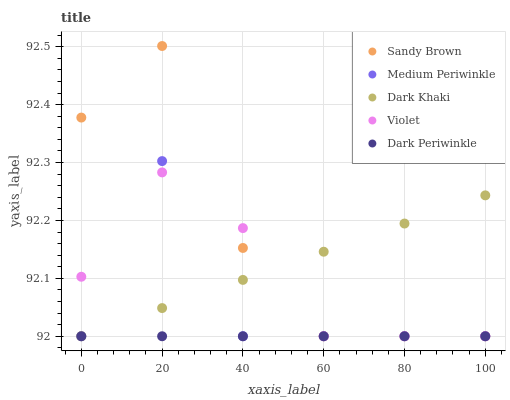Does Dark Periwinkle have the minimum area under the curve?
Answer yes or no. Yes. Does Sandy Brown have the maximum area under the curve?
Answer yes or no. Yes. Does Medium Periwinkle have the minimum area under the curve?
Answer yes or no. No. Does Medium Periwinkle have the maximum area under the curve?
Answer yes or no. No. Is Dark Periwinkle the smoothest?
Answer yes or no. Yes. Is Medium Periwinkle the roughest?
Answer yes or no. Yes. Is Sandy Brown the smoothest?
Answer yes or no. No. Is Sandy Brown the roughest?
Answer yes or no. No. Does Dark Khaki have the lowest value?
Answer yes or no. Yes. Does Sandy Brown have the highest value?
Answer yes or no. Yes. Does Medium Periwinkle have the highest value?
Answer yes or no. No. Does Dark Khaki intersect Medium Periwinkle?
Answer yes or no. Yes. Is Dark Khaki less than Medium Periwinkle?
Answer yes or no. No. Is Dark Khaki greater than Medium Periwinkle?
Answer yes or no. No. 